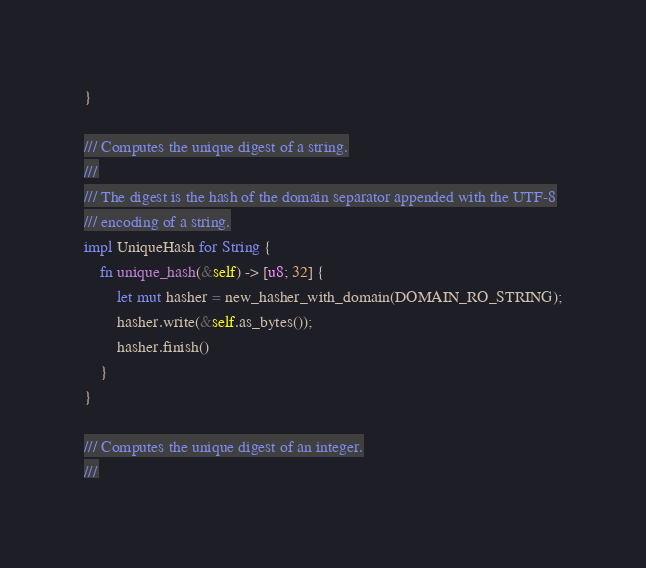<code> <loc_0><loc_0><loc_500><loc_500><_Rust_>}

/// Computes the unique digest of a string.
///
/// The digest is the hash of the domain separator appended with the UTF-8
/// encoding of a string.
impl UniqueHash for String {
    fn unique_hash(&self) -> [u8; 32] {
        let mut hasher = new_hasher_with_domain(DOMAIN_RO_STRING);
        hasher.write(&self.as_bytes());
        hasher.finish()
    }
}

/// Computes the unique digest of an integer.
///</code> 